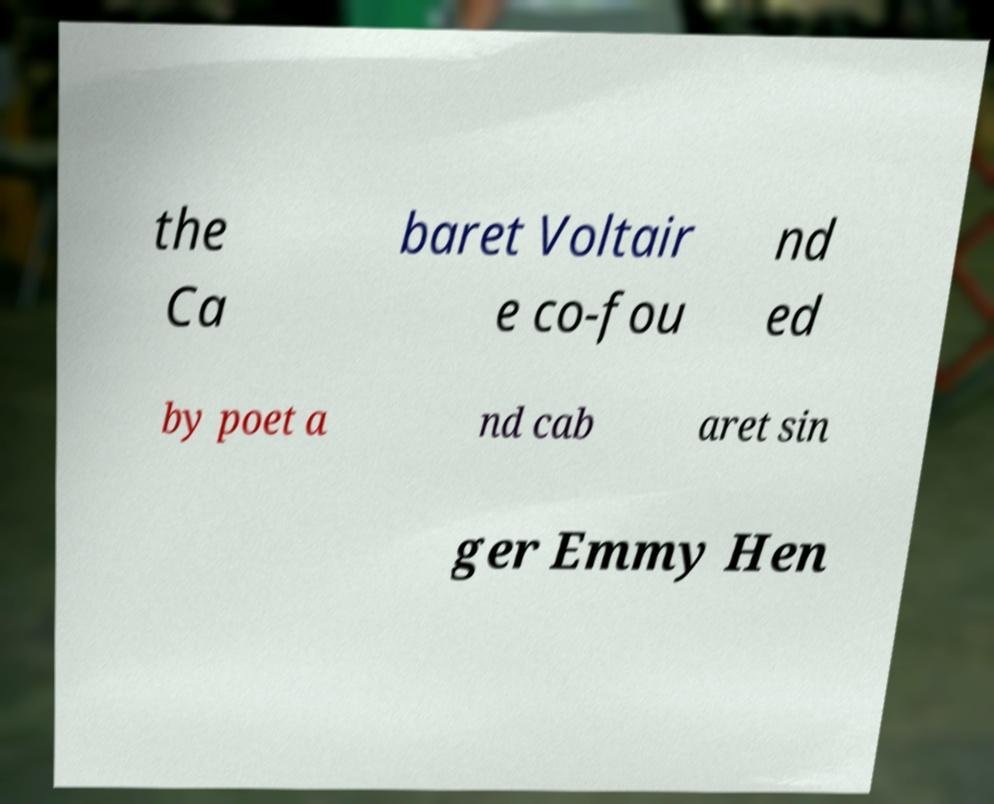Please read and relay the text visible in this image. What does it say? the Ca baret Voltair e co-fou nd ed by poet a nd cab aret sin ger Emmy Hen 